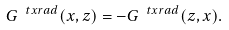<formula> <loc_0><loc_0><loc_500><loc_500>G ^ { \ t x { r a d } } ( x , z ) = - G ^ { \ t x { r a d } } ( z , x ) .</formula> 